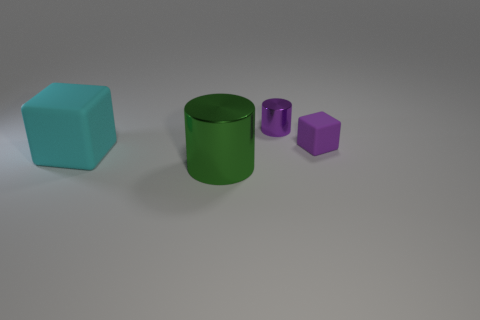There is a thing that is the same size as the green metallic cylinder; what is its color?
Your answer should be very brief. Cyan. What is the shape of the thing that is both in front of the purple cylinder and behind the cyan thing?
Your answer should be very brief. Cube. There is a rubber thing that is in front of the rubber cube right of the green metallic object; what size is it?
Your answer should be very brief. Large. How many matte cylinders are the same color as the small block?
Make the answer very short. 0. How many other objects are the same size as the green thing?
Make the answer very short. 1. What size is the object that is both right of the big green cylinder and on the left side of the small block?
Offer a very short reply. Small. How many big objects have the same shape as the small shiny object?
Your response must be concise. 1. What is the material of the small cylinder?
Your answer should be very brief. Metal. Does the big matte object have the same shape as the large green shiny object?
Ensure brevity in your answer.  No. Are there any small blocks made of the same material as the green cylinder?
Your answer should be very brief. No. 